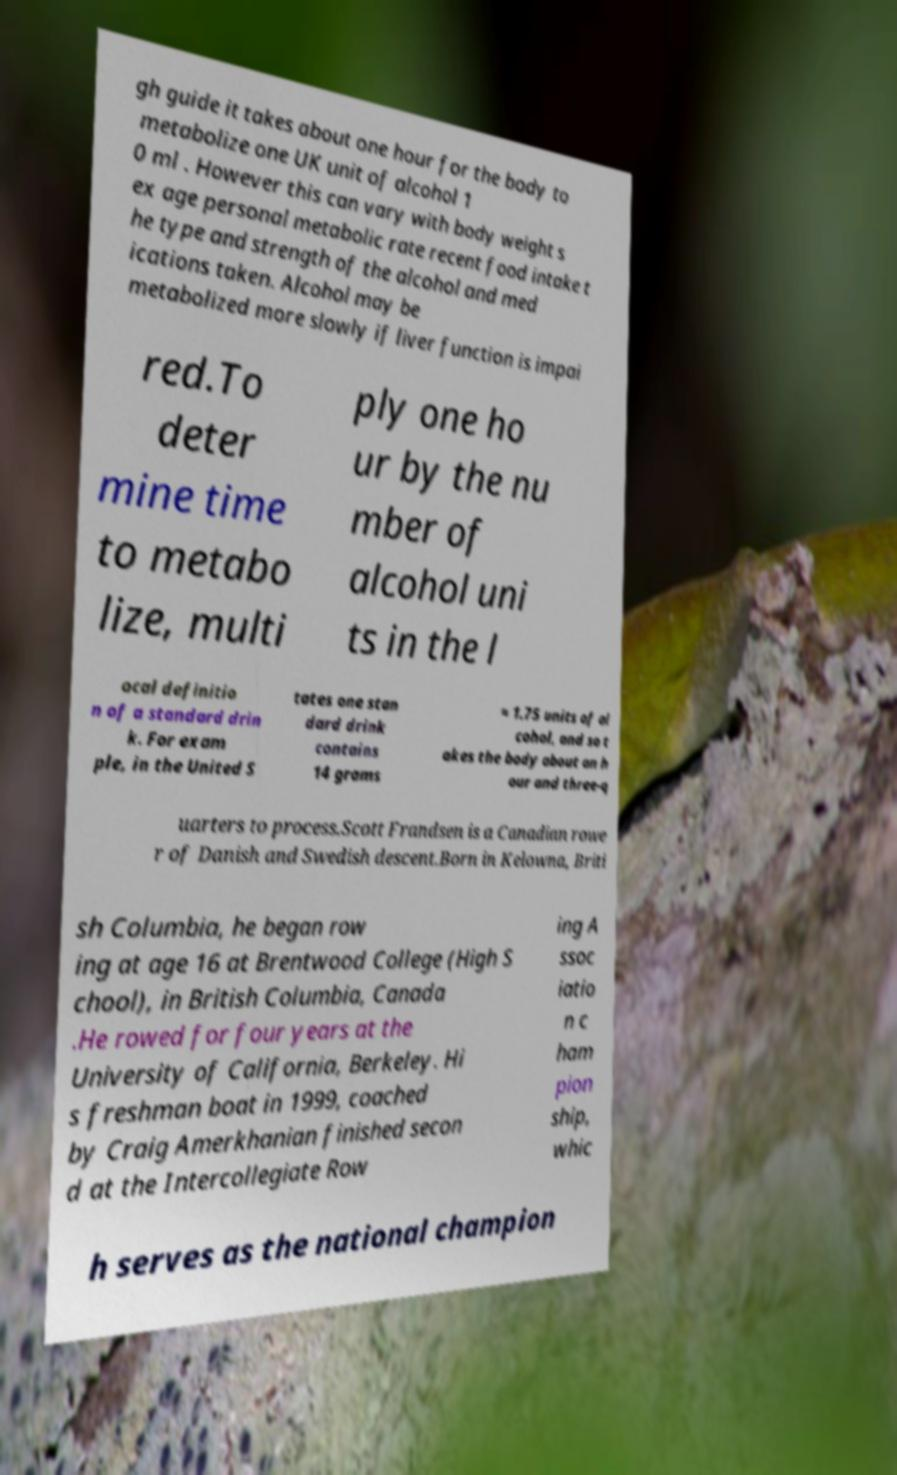There's text embedded in this image that I need extracted. Can you transcribe it verbatim? gh guide it takes about one hour for the body to metabolize one UK unit of alcohol 1 0 ml . However this can vary with body weight s ex age personal metabolic rate recent food intake t he type and strength of the alcohol and med ications taken. Alcohol may be metabolized more slowly if liver function is impai red.To deter mine time to metabo lize, multi ply one ho ur by the nu mber of alcohol uni ts in the l ocal definitio n of a standard drin k. For exam ple, in the United S tates one stan dard drink contains 14 grams ≈ 1.75 units of al cohol, and so t akes the body about an h our and three-q uarters to process.Scott Frandsen is a Canadian rowe r of Danish and Swedish descent.Born in Kelowna, Briti sh Columbia, he began row ing at age 16 at Brentwood College (High S chool), in British Columbia, Canada .He rowed for four years at the University of California, Berkeley. Hi s freshman boat in 1999, coached by Craig Amerkhanian finished secon d at the Intercollegiate Row ing A ssoc iatio n c ham pion ship, whic h serves as the national champion 